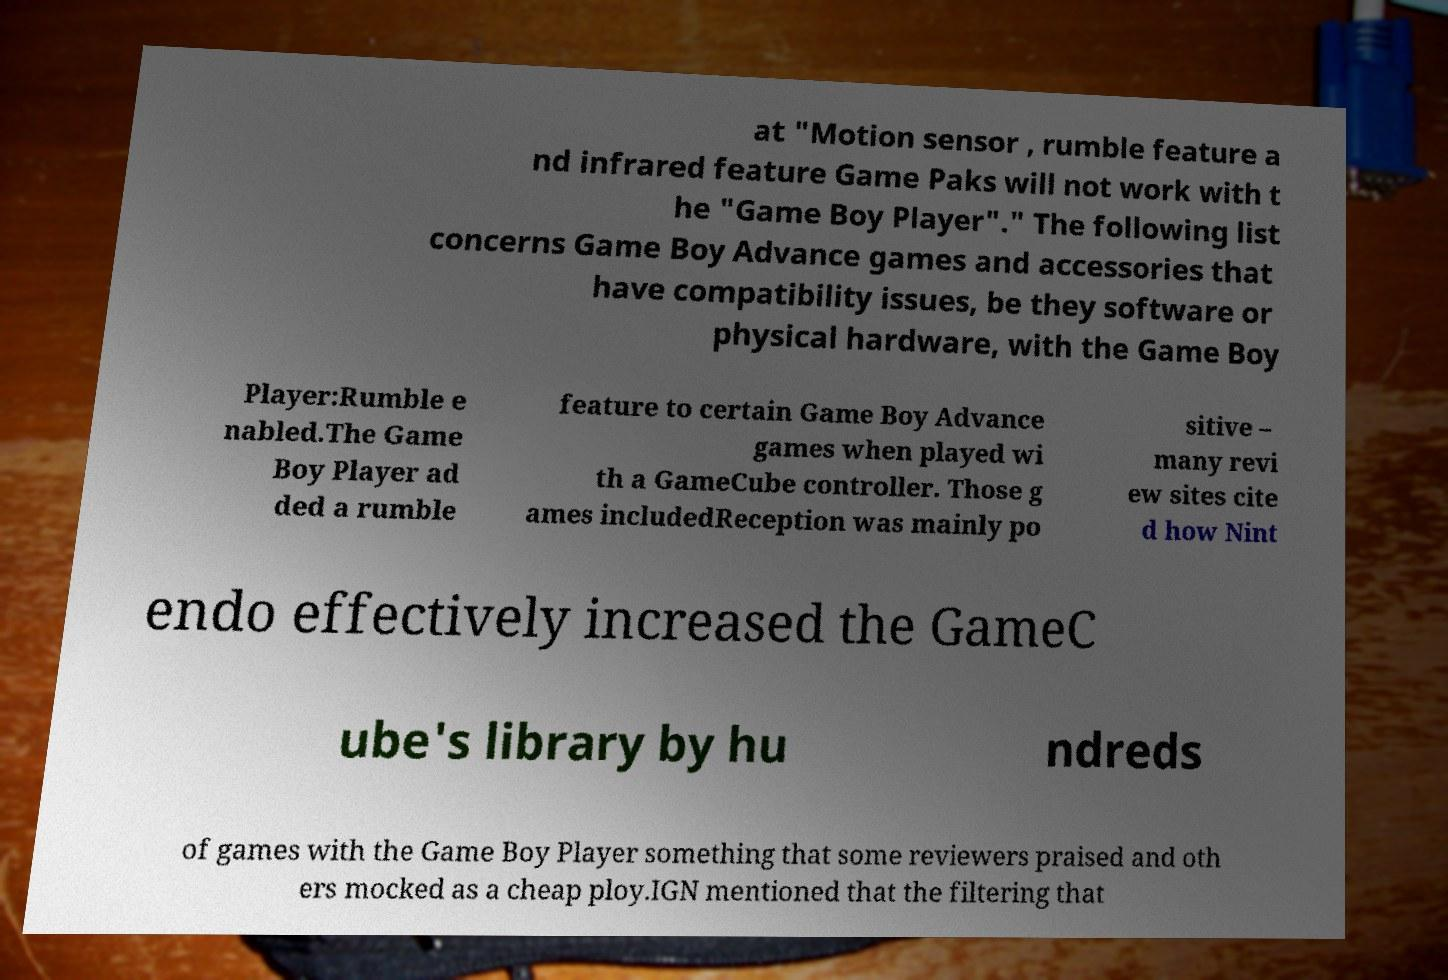For documentation purposes, I need the text within this image transcribed. Could you provide that? at "Motion sensor , rumble feature a nd infrared feature Game Paks will not work with t he "Game Boy Player"." The following list concerns Game Boy Advance games and accessories that have compatibility issues, be they software or physical hardware, with the Game Boy Player:Rumble e nabled.The Game Boy Player ad ded a rumble feature to certain Game Boy Advance games when played wi th a GameCube controller. Those g ames includedReception was mainly po sitive – many revi ew sites cite d how Nint endo effectively increased the GameC ube's library by hu ndreds of games with the Game Boy Player something that some reviewers praised and oth ers mocked as a cheap ploy.IGN mentioned that the filtering that 